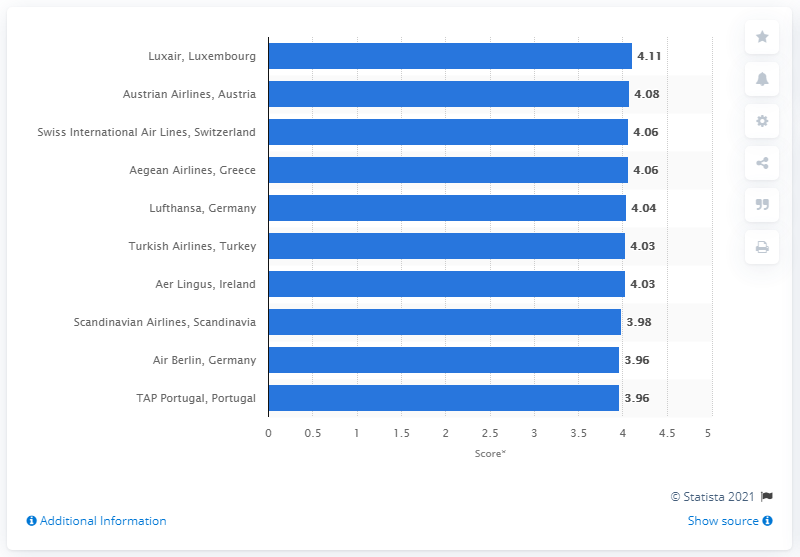List a handful of essential elements in this visual. Luxair received a score of 4.11 out of five. 